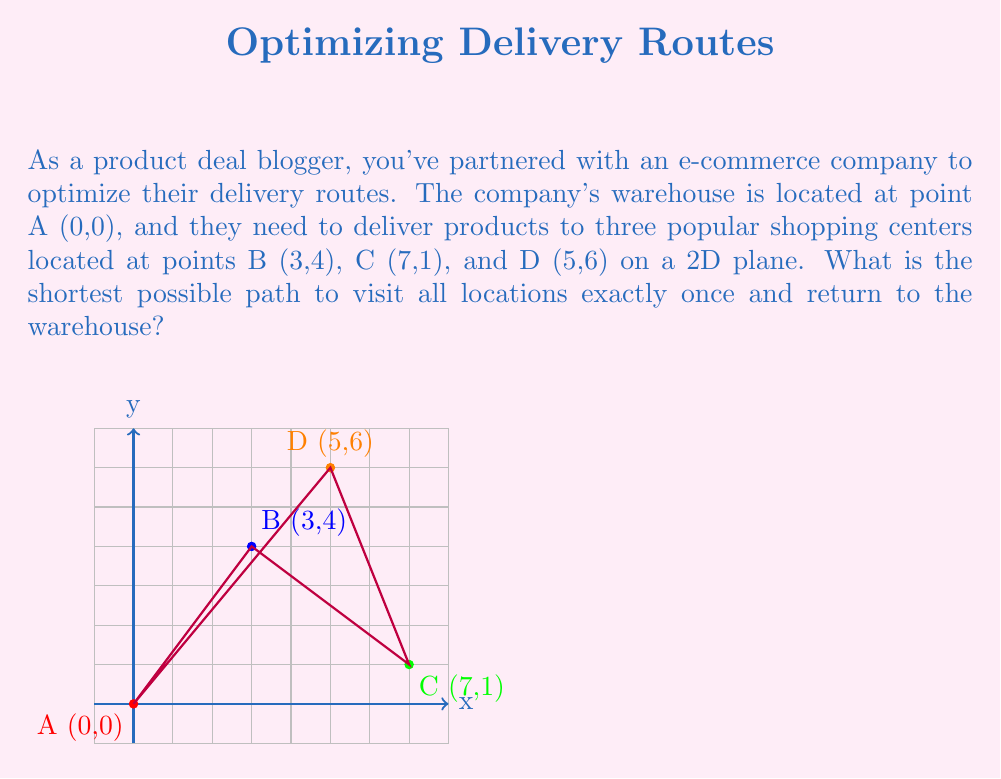Provide a solution to this math problem. To solve this problem, we need to use the concept of the Traveling Salesman Problem (TSP) in graph theory. Since there are only 4 points, we can solve this by calculating all possible routes and finding the shortest one.

Step 1: Calculate distances between all pairs of points using the distance formula:
$$d = \sqrt{(x_2-x_1)^2 + (y_2-y_1)^2}$$

AB = $\sqrt{(3-0)^2 + (4-0)^2} = 5$
AC = $\sqrt{(7-0)^2 + (1-0)^2} = \sqrt{50} \approx 7.07$
AD = $\sqrt{(5-0)^2 + (6-0)^2} = \sqrt{61} \approx 7.81$
BC = $\sqrt{(7-3)^2 + (1-4)^2} = 5$
BD = $\sqrt{(5-3)^2 + (6-4)^2} = 2\sqrt{5} \approx 4.47$
CD = $\sqrt{(5-7)^2 + (6-1)^2} = \sqrt{34} \approx 5.83$

Step 2: List all possible routes (starting and ending at A):
1. A-B-C-D-A
2. A-B-D-C-A
3. A-C-B-D-A
4. A-C-D-B-A
5. A-D-B-C-A
6. A-D-C-B-A

Step 3: Calculate the total distance for each route:
1. A-B-C-D-A = 5 + 5 + 5.83 + 7.81 = 23.64
2. A-B-D-C-A = 5 + 4.47 + 5.83 + 7.07 = 22.37
3. A-C-B-D-A = 7.07 + 5 + 4.47 + 7.81 = 24.35
4. A-C-D-B-A = 7.07 + 5.83 + 4.47 + 5 = 22.37
5. A-D-B-C-A = 7.81 + 4.47 + 5 + 7.07 = 24.35
6. A-D-C-B-A = 7.81 + 5.83 + 5 + 5 = 23.64

Step 4: Identify the shortest path:
The shortest paths are routes 2 and 4, both with a total distance of 22.37.
Answer: A-B-D-C-A or A-C-D-B-A, with total distance $22.37$ 